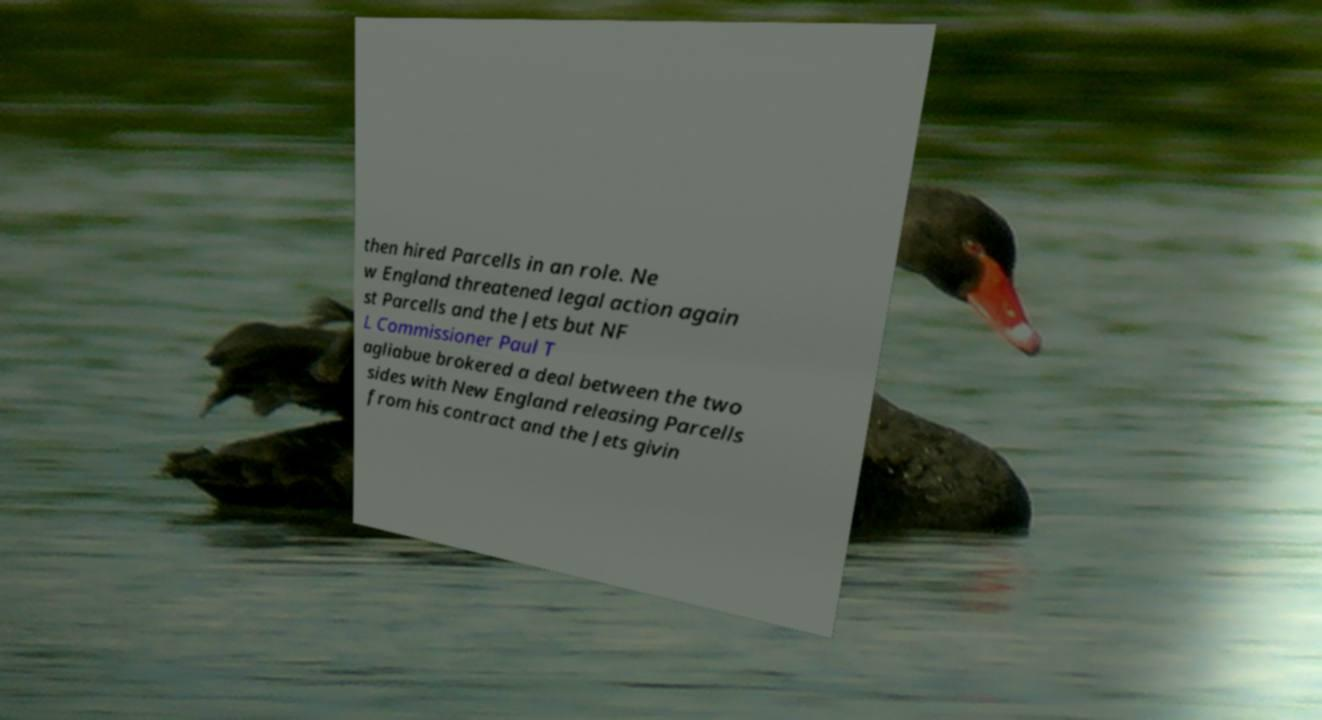Please identify and transcribe the text found in this image. then hired Parcells in an role. Ne w England threatened legal action again st Parcells and the Jets but NF L Commissioner Paul T agliabue brokered a deal between the two sides with New England releasing Parcells from his contract and the Jets givin 